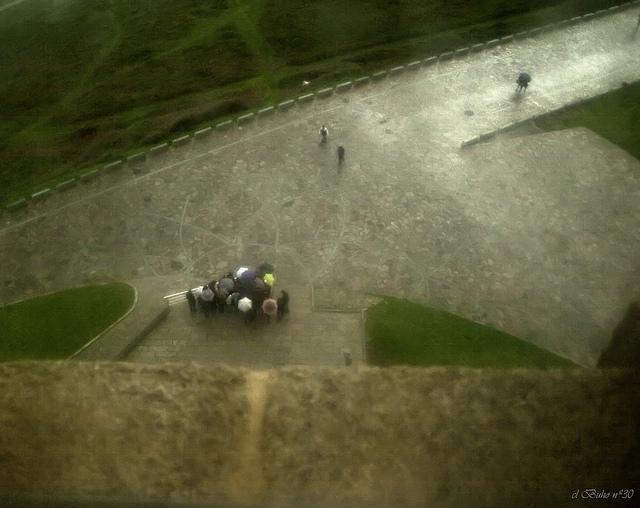What are the objects held in the small group of people at the mouth of this road?
Choose the right answer and clarify with the format: 'Answer: answer
Rationale: rationale.'
Options: Rainjackets, pianos, windex, umbrellas. Answer: umbrellas.
Rationale: The object is an umbrella. 